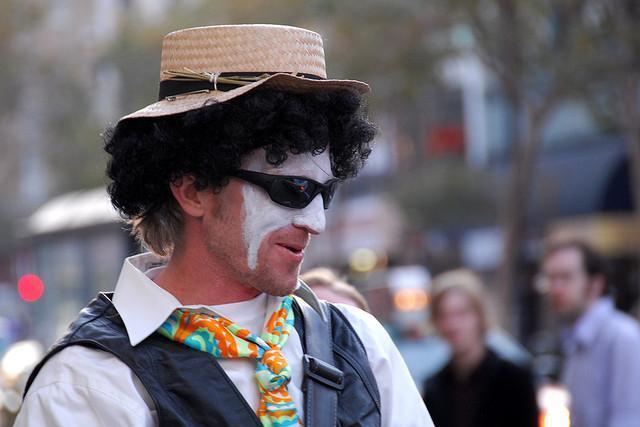How many people are in the background?
Give a very brief answer. 3. How many buses are there?
Give a very brief answer. 1. How many people can be seen?
Give a very brief answer. 3. 